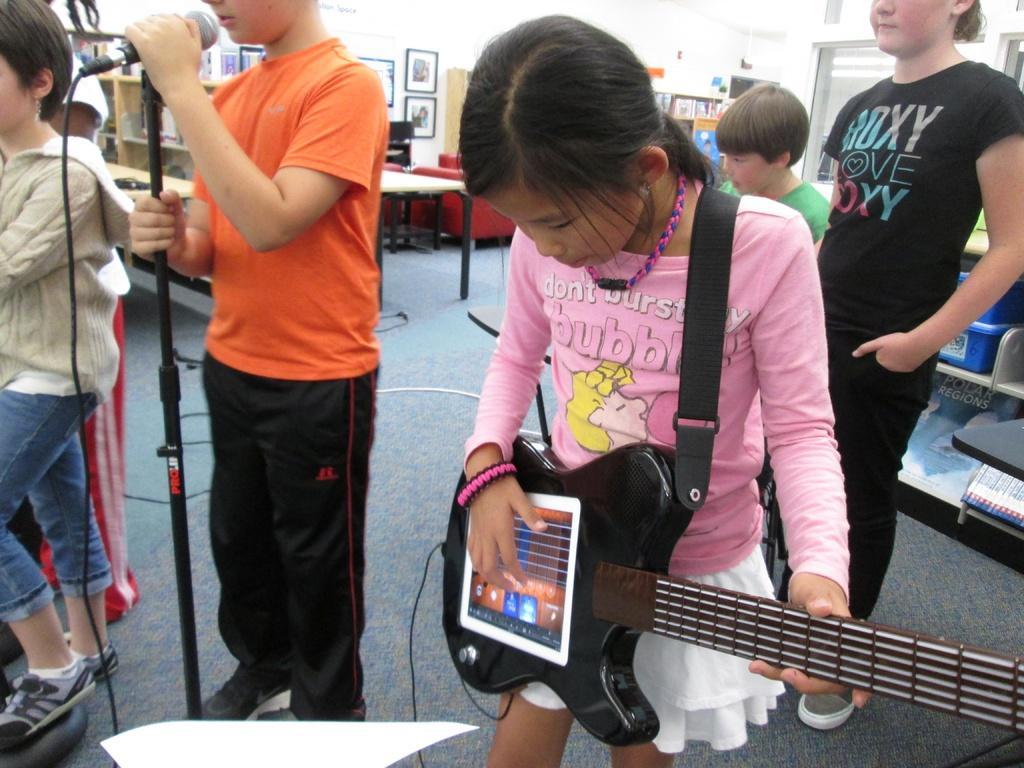In one or two sentences, can you explain what this image depicts? In this picture. We see a boy holding a microphone in his hand and a girl playing a guitar and few people standing at the back and side and we see a table and photo frames on the wall. 